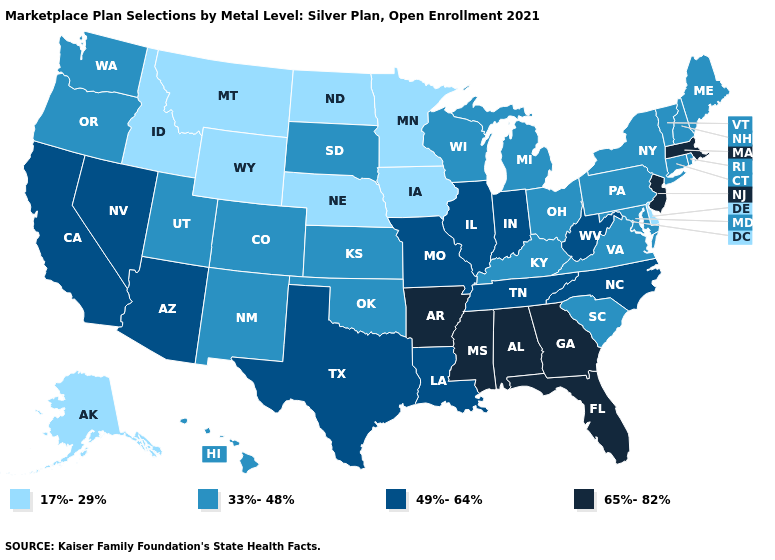Is the legend a continuous bar?
Keep it brief. No. What is the highest value in states that border New York?
Be succinct. 65%-82%. Which states have the lowest value in the USA?
Write a very short answer. Alaska, Delaware, Idaho, Iowa, Minnesota, Montana, Nebraska, North Dakota, Wyoming. Which states have the lowest value in the South?
Be succinct. Delaware. Does New York have the highest value in the USA?
Short answer required. No. What is the value of Utah?
Answer briefly. 33%-48%. What is the value of Alaska?
Be succinct. 17%-29%. Name the states that have a value in the range 49%-64%?
Write a very short answer. Arizona, California, Illinois, Indiana, Louisiana, Missouri, Nevada, North Carolina, Tennessee, Texas, West Virginia. What is the value of Virginia?
Be succinct. 33%-48%. Which states have the highest value in the USA?
Be succinct. Alabama, Arkansas, Florida, Georgia, Massachusetts, Mississippi, New Jersey. What is the lowest value in the MidWest?
Concise answer only. 17%-29%. Does Wyoming have the lowest value in the USA?
Keep it brief. Yes. Does the map have missing data?
Give a very brief answer. No. Among the states that border Iowa , does Nebraska have the lowest value?
Be succinct. Yes. Name the states that have a value in the range 33%-48%?
Concise answer only. Colorado, Connecticut, Hawaii, Kansas, Kentucky, Maine, Maryland, Michigan, New Hampshire, New Mexico, New York, Ohio, Oklahoma, Oregon, Pennsylvania, Rhode Island, South Carolina, South Dakota, Utah, Vermont, Virginia, Washington, Wisconsin. 